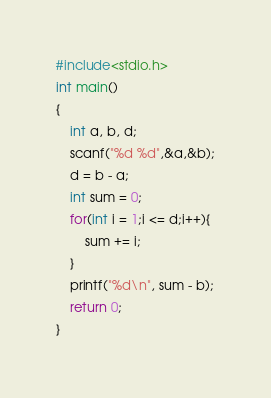<code> <loc_0><loc_0><loc_500><loc_500><_C_>#include<stdio.h>
int main()
{
    int a, b, d;
    scanf("%d %d",&a,&b);
    d = b - a;
    int sum = 0;
    for(int i = 1;i <= d;i++){
        sum += i;
    }
    printf("%d\n", sum - b);
    return 0;
}
</code> 